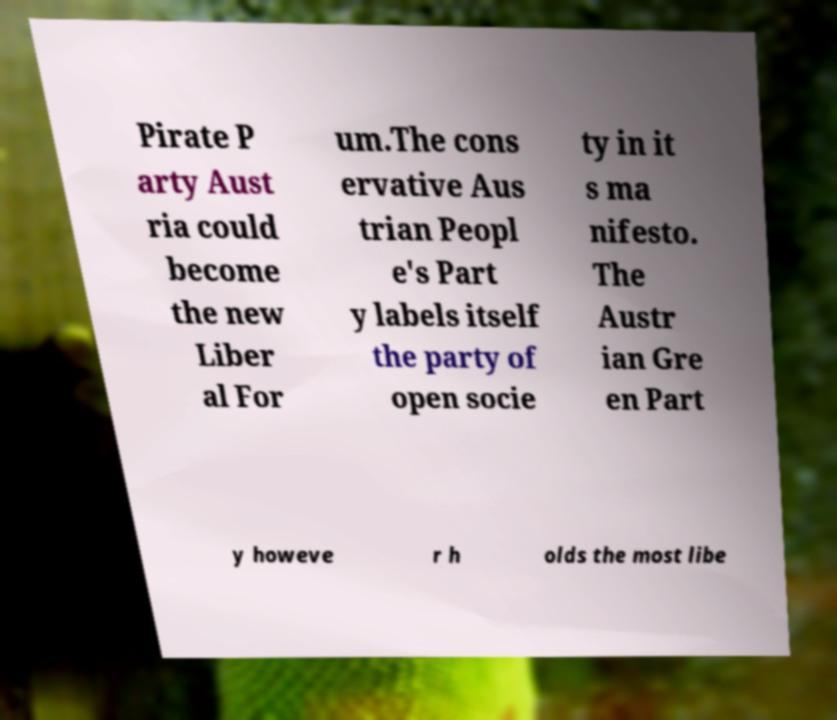Can you read and provide the text displayed in the image?This photo seems to have some interesting text. Can you extract and type it out for me? Pirate P arty Aust ria could become the new Liber al For um.The cons ervative Aus trian Peopl e's Part y labels itself the party of open socie ty in it s ma nifesto. The Austr ian Gre en Part y howeve r h olds the most libe 